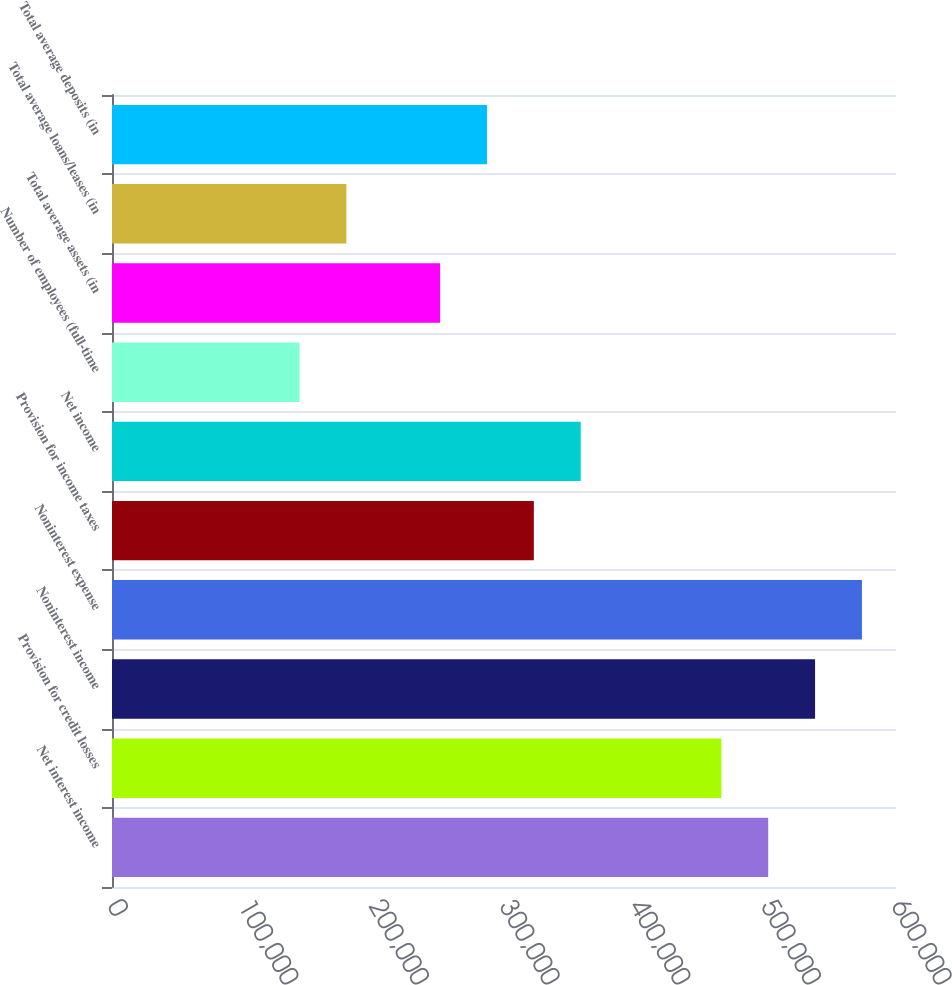Convert chart to OTSL. <chart><loc_0><loc_0><loc_500><loc_500><bar_chart><fcel>Net interest income<fcel>Provision for credit losses<fcel>Noninterest income<fcel>Noninterest expense<fcel>Provision for income taxes<fcel>Net income<fcel>Number of employees (full-time<fcel>Total average assets (in<fcel>Total average loans/leases (in<fcel>Total average deposits (in<nl><fcel>502189<fcel>466318<fcel>538059<fcel>573930<fcel>322837<fcel>358707<fcel>143484<fcel>251096<fcel>179355<fcel>286966<nl></chart> 